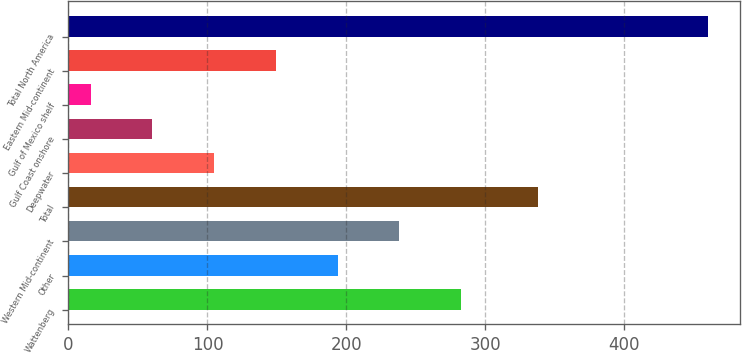Convert chart. <chart><loc_0><loc_0><loc_500><loc_500><bar_chart><fcel>Wattenberg<fcel>Other<fcel>Western Mid-continent<fcel>Total<fcel>Deepwater<fcel>Gulf Coast onshore<fcel>Gulf of Mexico shelf<fcel>Eastern Mid-continent<fcel>Total North America<nl><fcel>282.4<fcel>193.6<fcel>238<fcel>338<fcel>104.8<fcel>60.4<fcel>16<fcel>149.2<fcel>460<nl></chart> 